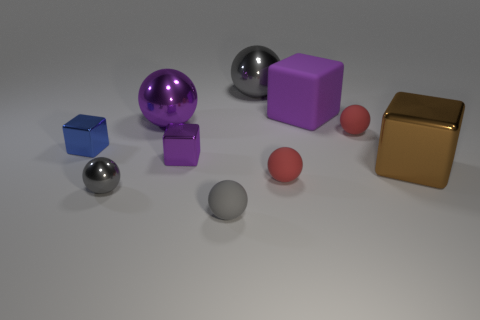How many things are large blocks or red matte spheres behind the big brown metallic object?
Offer a terse response. 3. Is the number of large brown shiny things greater than the number of small brown metal cylinders?
Give a very brief answer. Yes. What is the size of the shiny thing that is the same color as the small metallic ball?
Give a very brief answer. Large. Are there any purple cylinders that have the same material as the small blue block?
Provide a succinct answer. No. The big object that is both on the right side of the big purple shiny ball and left of the big purple cube has what shape?
Your answer should be compact. Sphere. How many other objects are the same shape as the small blue object?
Give a very brief answer. 3. What is the size of the purple metal sphere?
Your answer should be compact. Large. What number of objects are either cubes or gray shiny spheres?
Make the answer very short. 6. There is a purple object that is in front of the small blue cube; what is its size?
Ensure brevity in your answer.  Small. What color is the big thing that is both in front of the big gray object and on the left side of the large purple matte block?
Make the answer very short. Purple. 